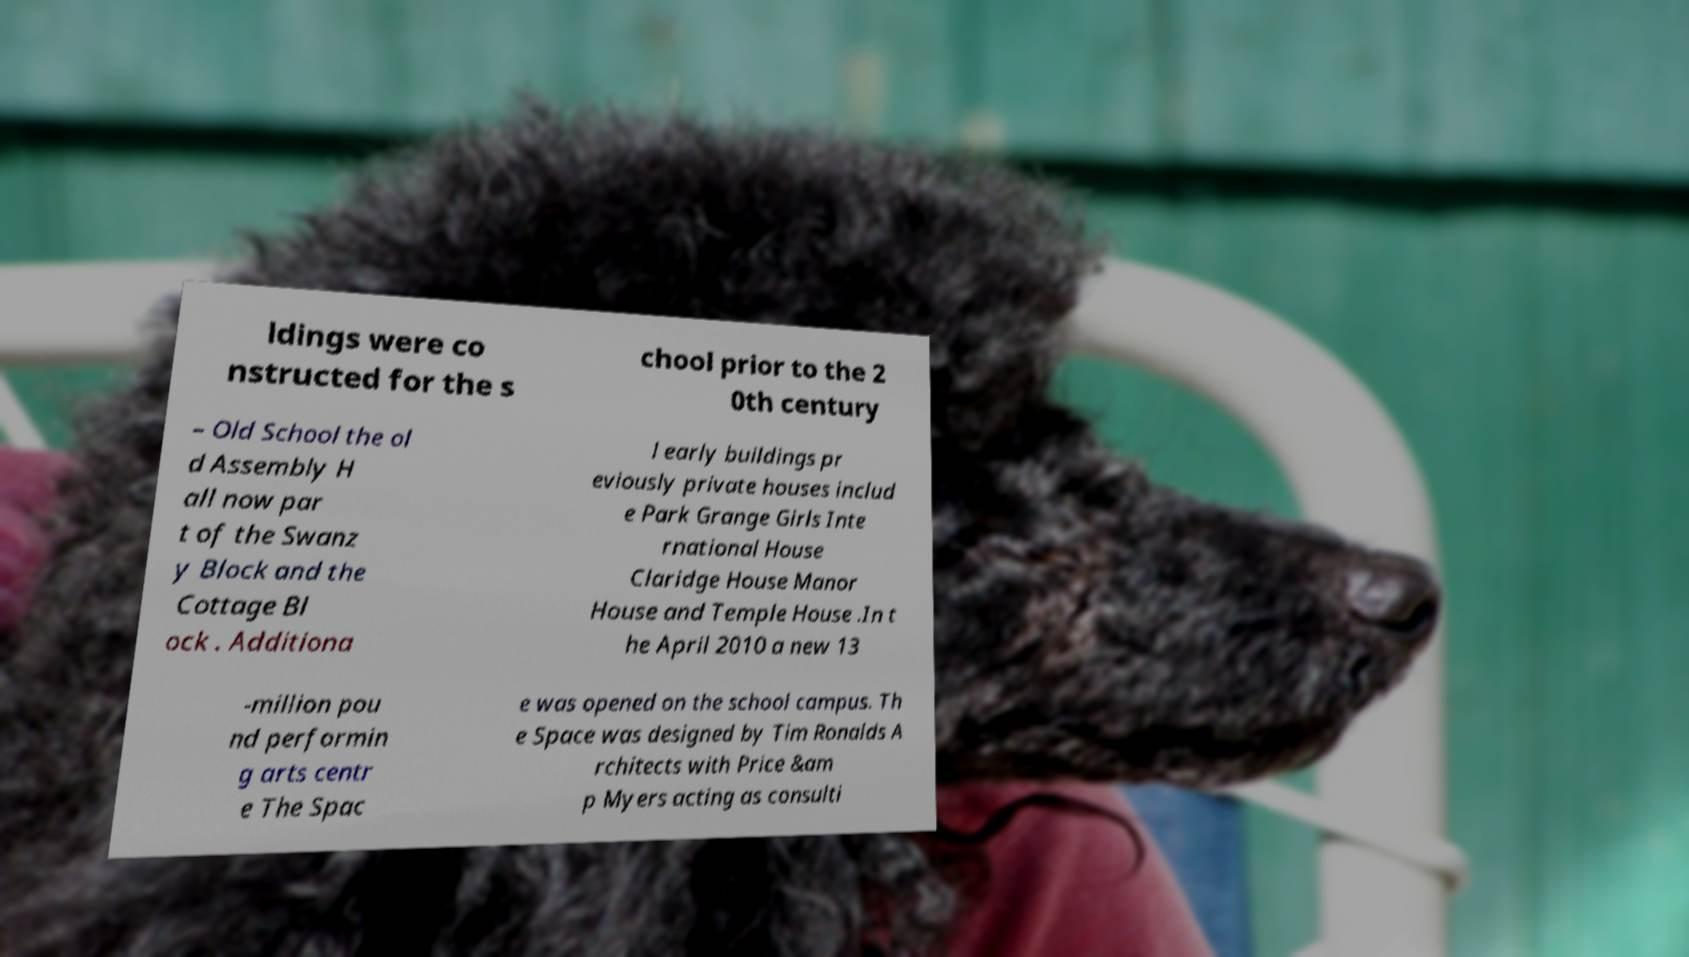Could you assist in decoding the text presented in this image and type it out clearly? ldings were co nstructed for the s chool prior to the 2 0th century – Old School the ol d Assembly H all now par t of the Swanz y Block and the Cottage Bl ock . Additiona l early buildings pr eviously private houses includ e Park Grange Girls Inte rnational House Claridge House Manor House and Temple House .In t he April 2010 a new 13 -million pou nd performin g arts centr e The Spac e was opened on the school campus. Th e Space was designed by Tim Ronalds A rchitects with Price &am p Myers acting as consulti 